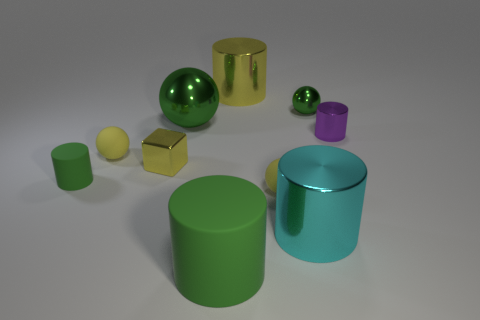Subtract 1 spheres. How many spheres are left? 3 Subtract all big green cylinders. How many cylinders are left? 4 Subtract all cyan cylinders. How many cylinders are left? 4 Subtract all blue spheres. Subtract all purple blocks. How many spheres are left? 4 Subtract all blocks. How many objects are left? 9 Add 5 tiny cyan shiny things. How many tiny cyan shiny things exist? 5 Subtract 0 brown balls. How many objects are left? 10 Subtract all matte balls. Subtract all large yellow metallic cylinders. How many objects are left? 7 Add 4 cylinders. How many cylinders are left? 9 